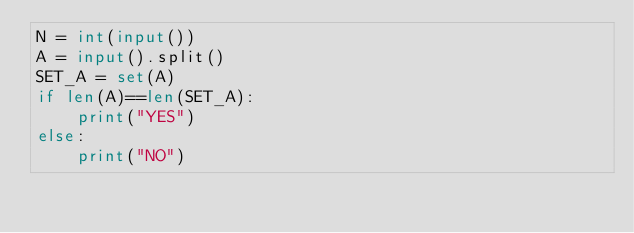Convert code to text. <code><loc_0><loc_0><loc_500><loc_500><_Python_>N = int(input())
A = input().split()
SET_A = set(A)
if len(A)==len(SET_A):
    print("YES")
else:
    print("NO")</code> 